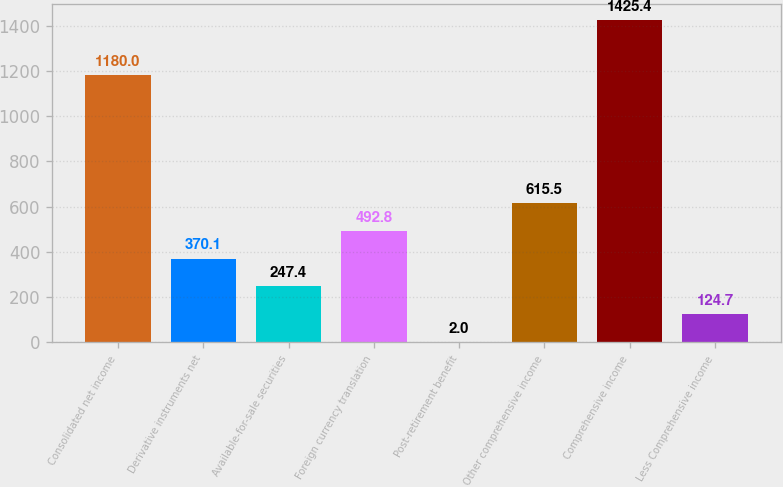<chart> <loc_0><loc_0><loc_500><loc_500><bar_chart><fcel>Consolidated net income<fcel>Derivative instruments net<fcel>Available-for-sale securities<fcel>Foreign currency translation<fcel>Post-retirement benefit<fcel>Other comprehensive income<fcel>Comprehensive income<fcel>Less Comprehensive income<nl><fcel>1180<fcel>370.1<fcel>247.4<fcel>492.8<fcel>2<fcel>615.5<fcel>1425.4<fcel>124.7<nl></chart> 